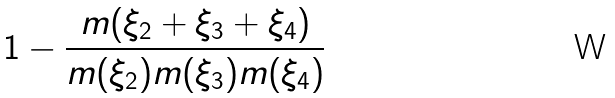<formula> <loc_0><loc_0><loc_500><loc_500>1 - \frac { m ( \xi _ { 2 } + \xi _ { 3 } + \xi _ { 4 } ) } { m ( \xi _ { 2 } ) m ( \xi _ { 3 } ) m ( \xi _ { 4 } ) }</formula> 